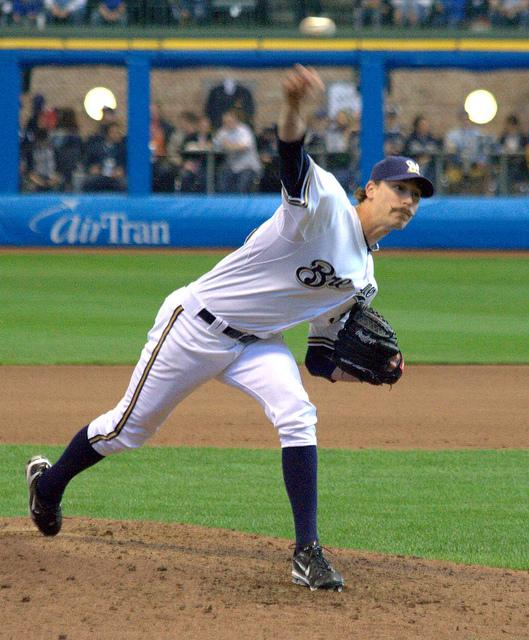To whom is this ball thrown? batter 